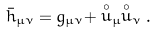Convert formula to latex. <formula><loc_0><loc_0><loc_500><loc_500>\bar { h } _ { \mu \nu } = g _ { \mu \nu } + \stackrel { \circ } u _ { \mu } \stackrel { \circ } u _ { \nu } .</formula> 